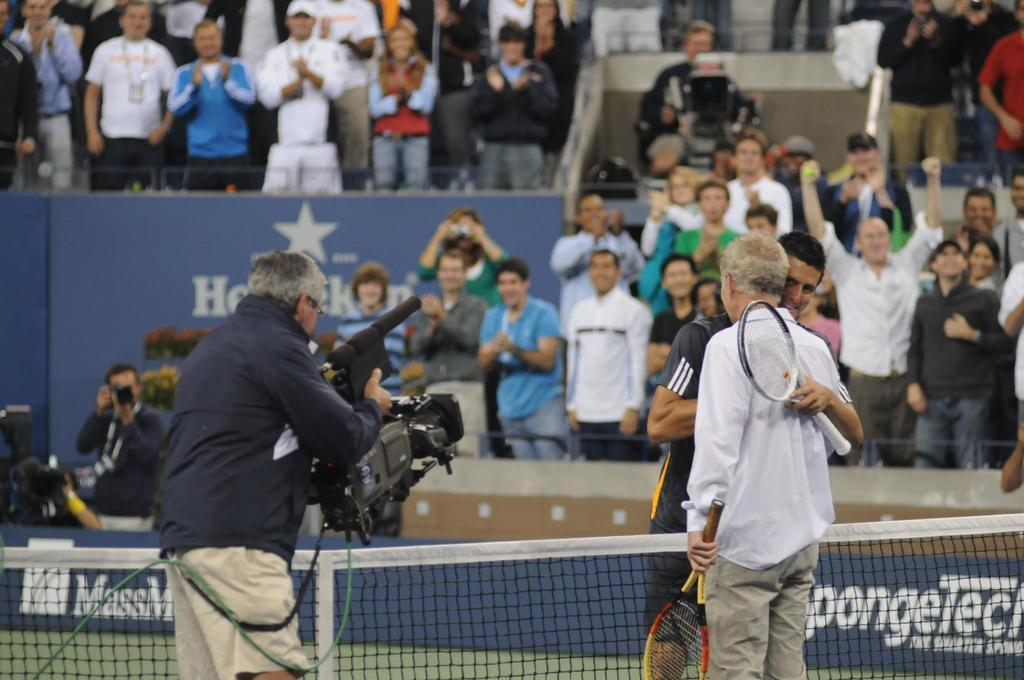Provide a one-sentence caption for the provided image. Heineken ad in the background of a tennis match. 